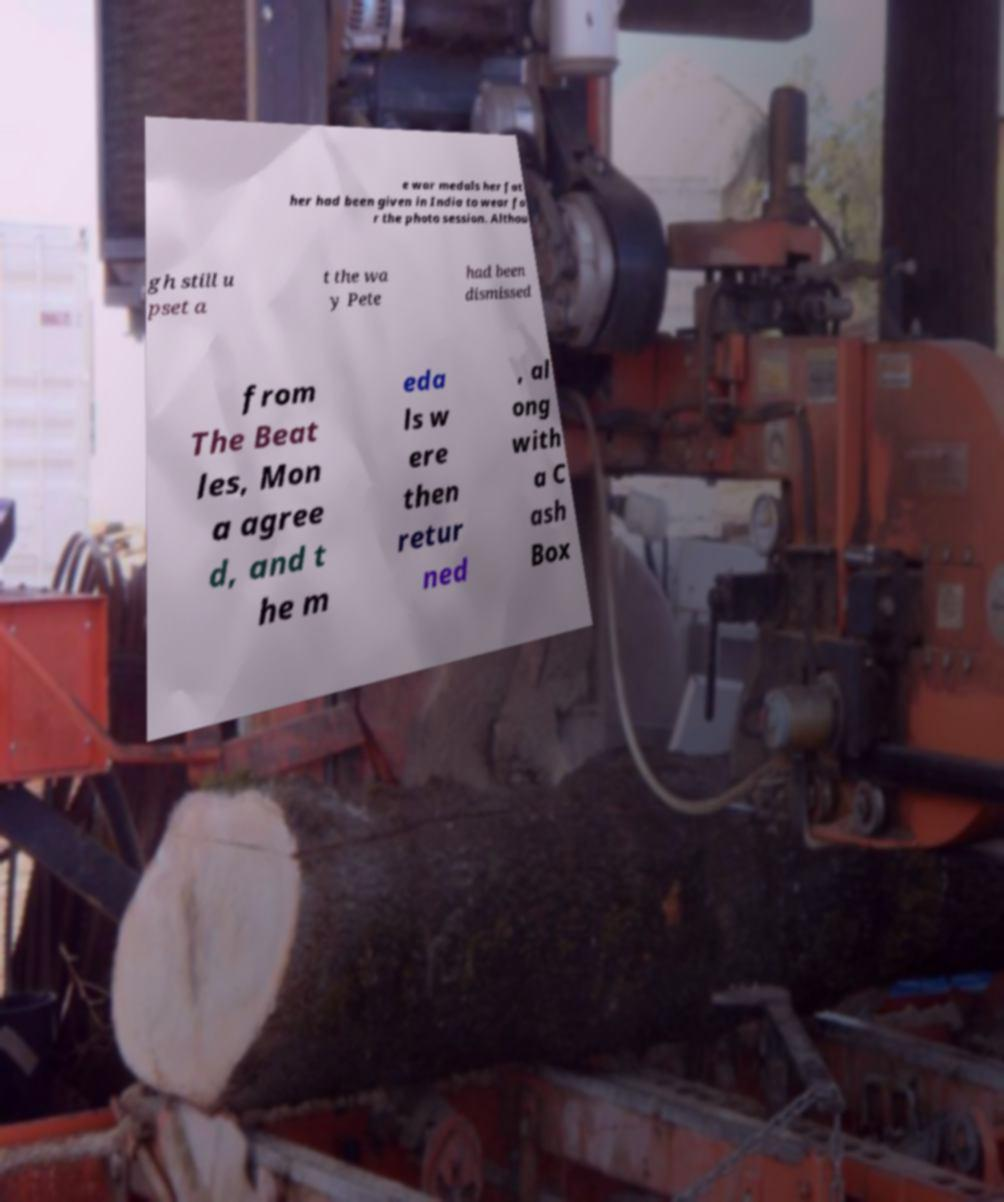Please identify and transcribe the text found in this image. e war medals her fat her had been given in India to wear fo r the photo session. Althou gh still u pset a t the wa y Pete had been dismissed from The Beat les, Mon a agree d, and t he m eda ls w ere then retur ned , al ong with a C ash Box 